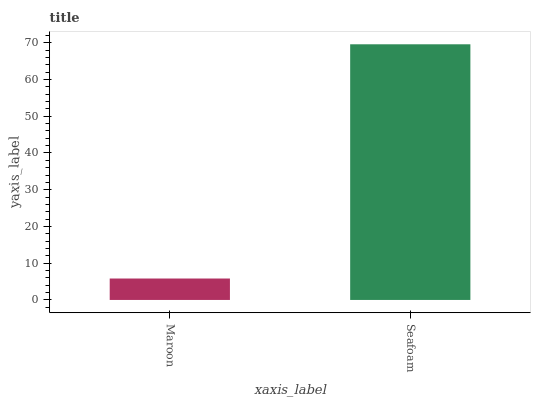Is Maroon the minimum?
Answer yes or no. Yes. Is Seafoam the maximum?
Answer yes or no. Yes. Is Seafoam the minimum?
Answer yes or no. No. Is Seafoam greater than Maroon?
Answer yes or no. Yes. Is Maroon less than Seafoam?
Answer yes or no. Yes. Is Maroon greater than Seafoam?
Answer yes or no. No. Is Seafoam less than Maroon?
Answer yes or no. No. Is Seafoam the high median?
Answer yes or no. Yes. Is Maroon the low median?
Answer yes or no. Yes. Is Maroon the high median?
Answer yes or no. No. Is Seafoam the low median?
Answer yes or no. No. 